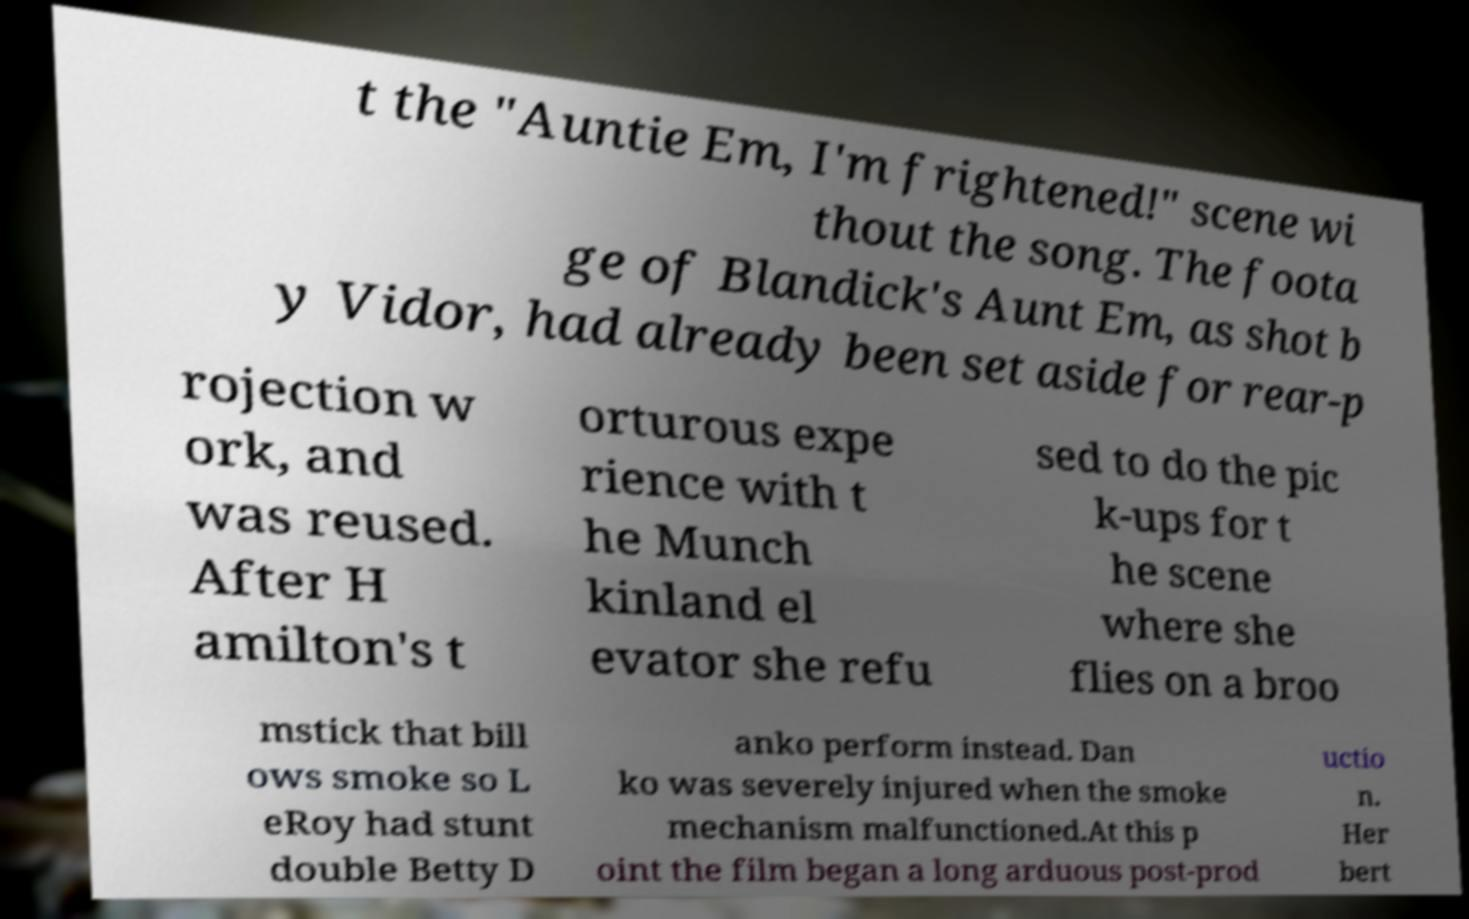Can you accurately transcribe the text from the provided image for me? t the "Auntie Em, I'm frightened!" scene wi thout the song. The foota ge of Blandick's Aunt Em, as shot b y Vidor, had already been set aside for rear-p rojection w ork, and was reused. After H amilton's t orturous expe rience with t he Munch kinland el evator she refu sed to do the pic k-ups for t he scene where she flies on a broo mstick that bill ows smoke so L eRoy had stunt double Betty D anko perform instead. Dan ko was severely injured when the smoke mechanism malfunctioned.At this p oint the film began a long arduous post-prod uctio n. Her bert 